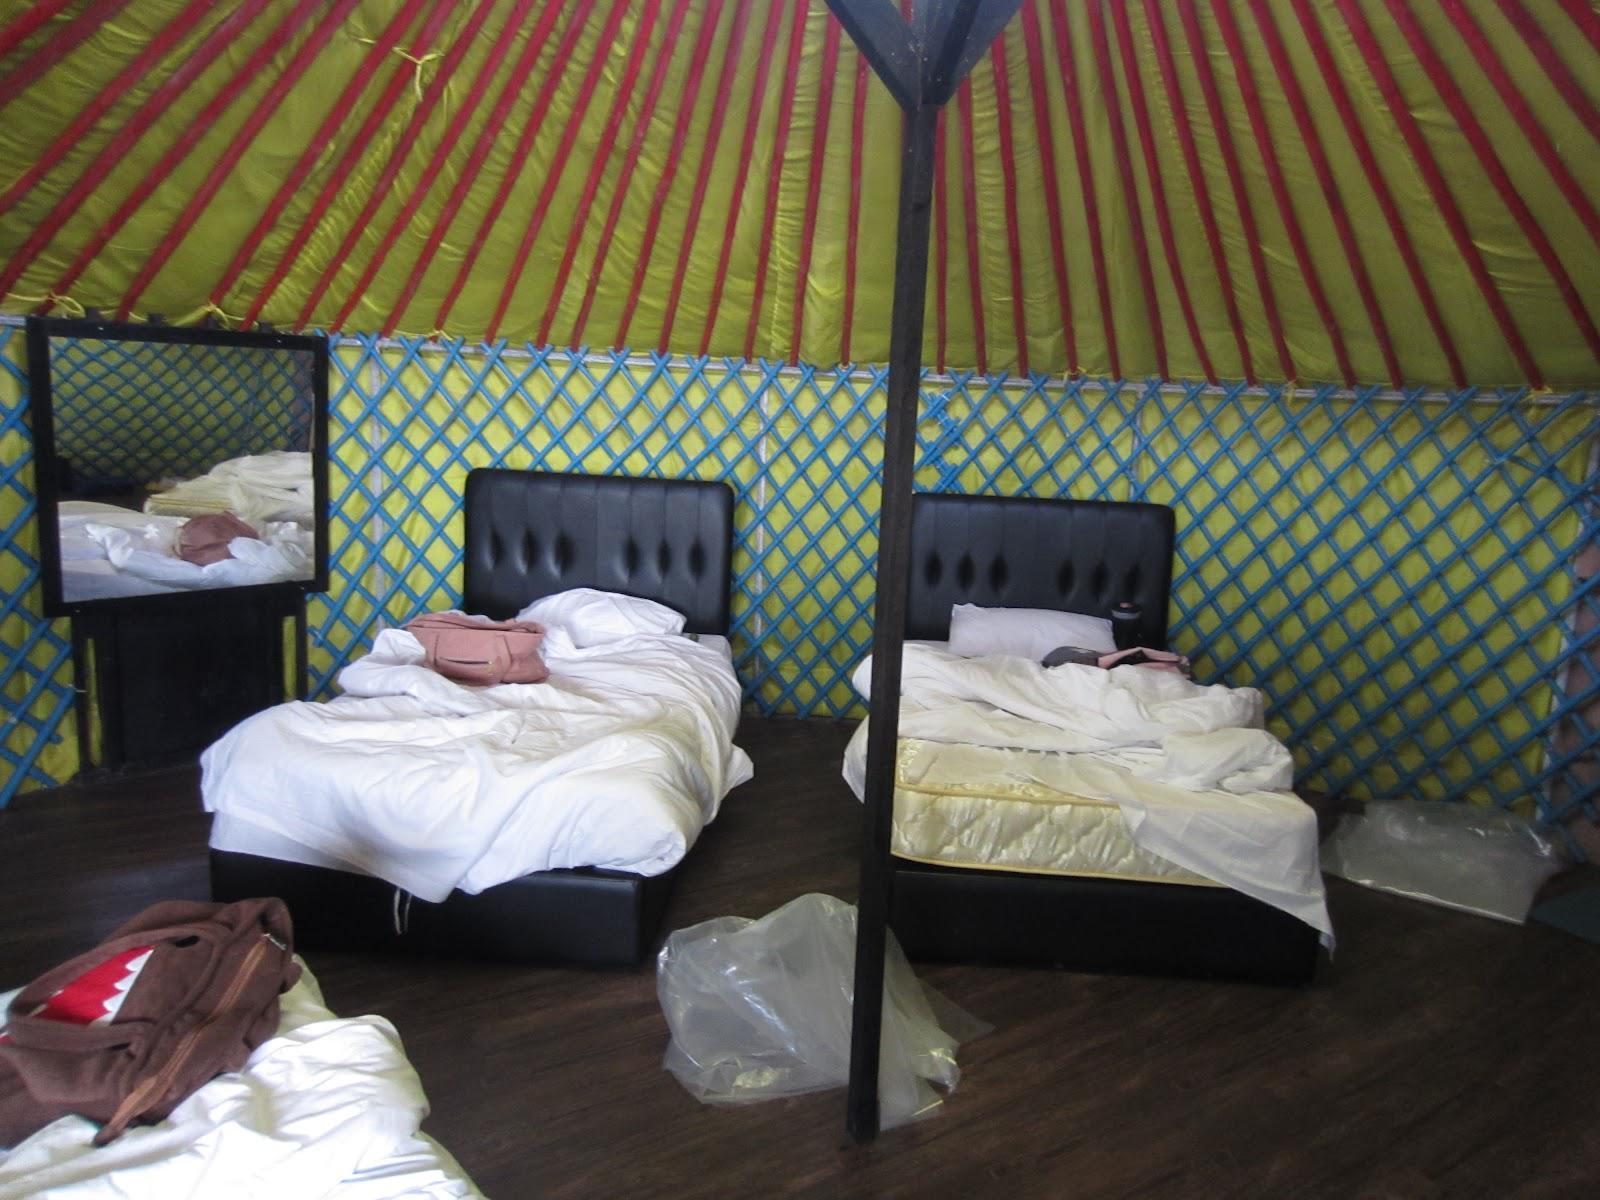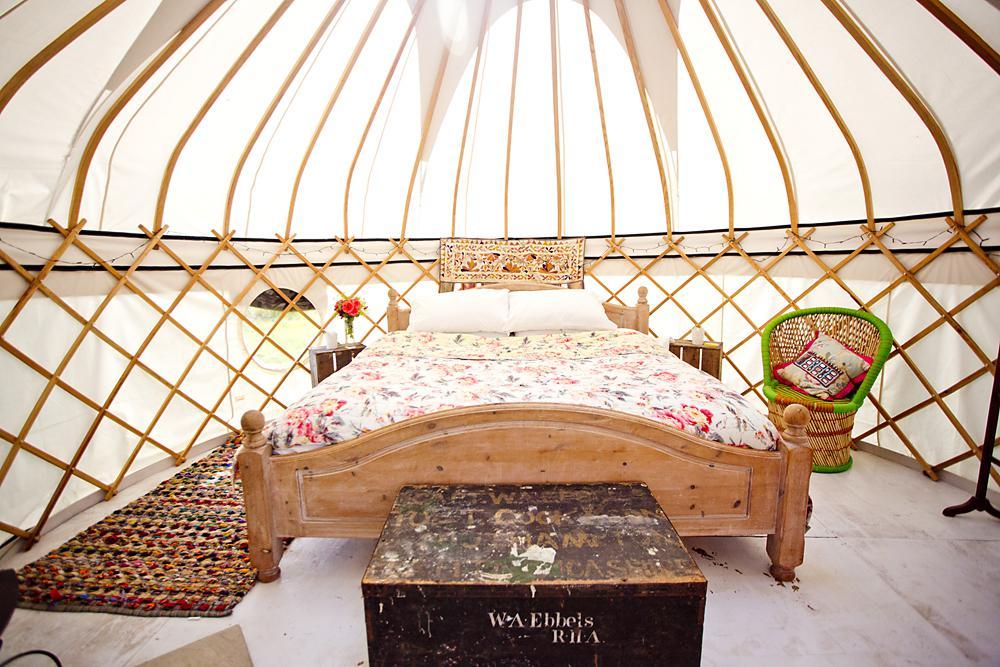The first image is the image on the left, the second image is the image on the right. Considering the images on both sides, is "Both images show the exterior of a dome-topped round building, its walls covered in white with a repeating blue symbol." valid? Answer yes or no. No. The first image is the image on the left, the second image is the image on the right. Evaluate the accuracy of this statement regarding the images: "One interior image of a yurt shows a bedroom with one wide bed with a headboard and a trunk sitting at the end of the bed.". Is it true? Answer yes or no. Yes. 